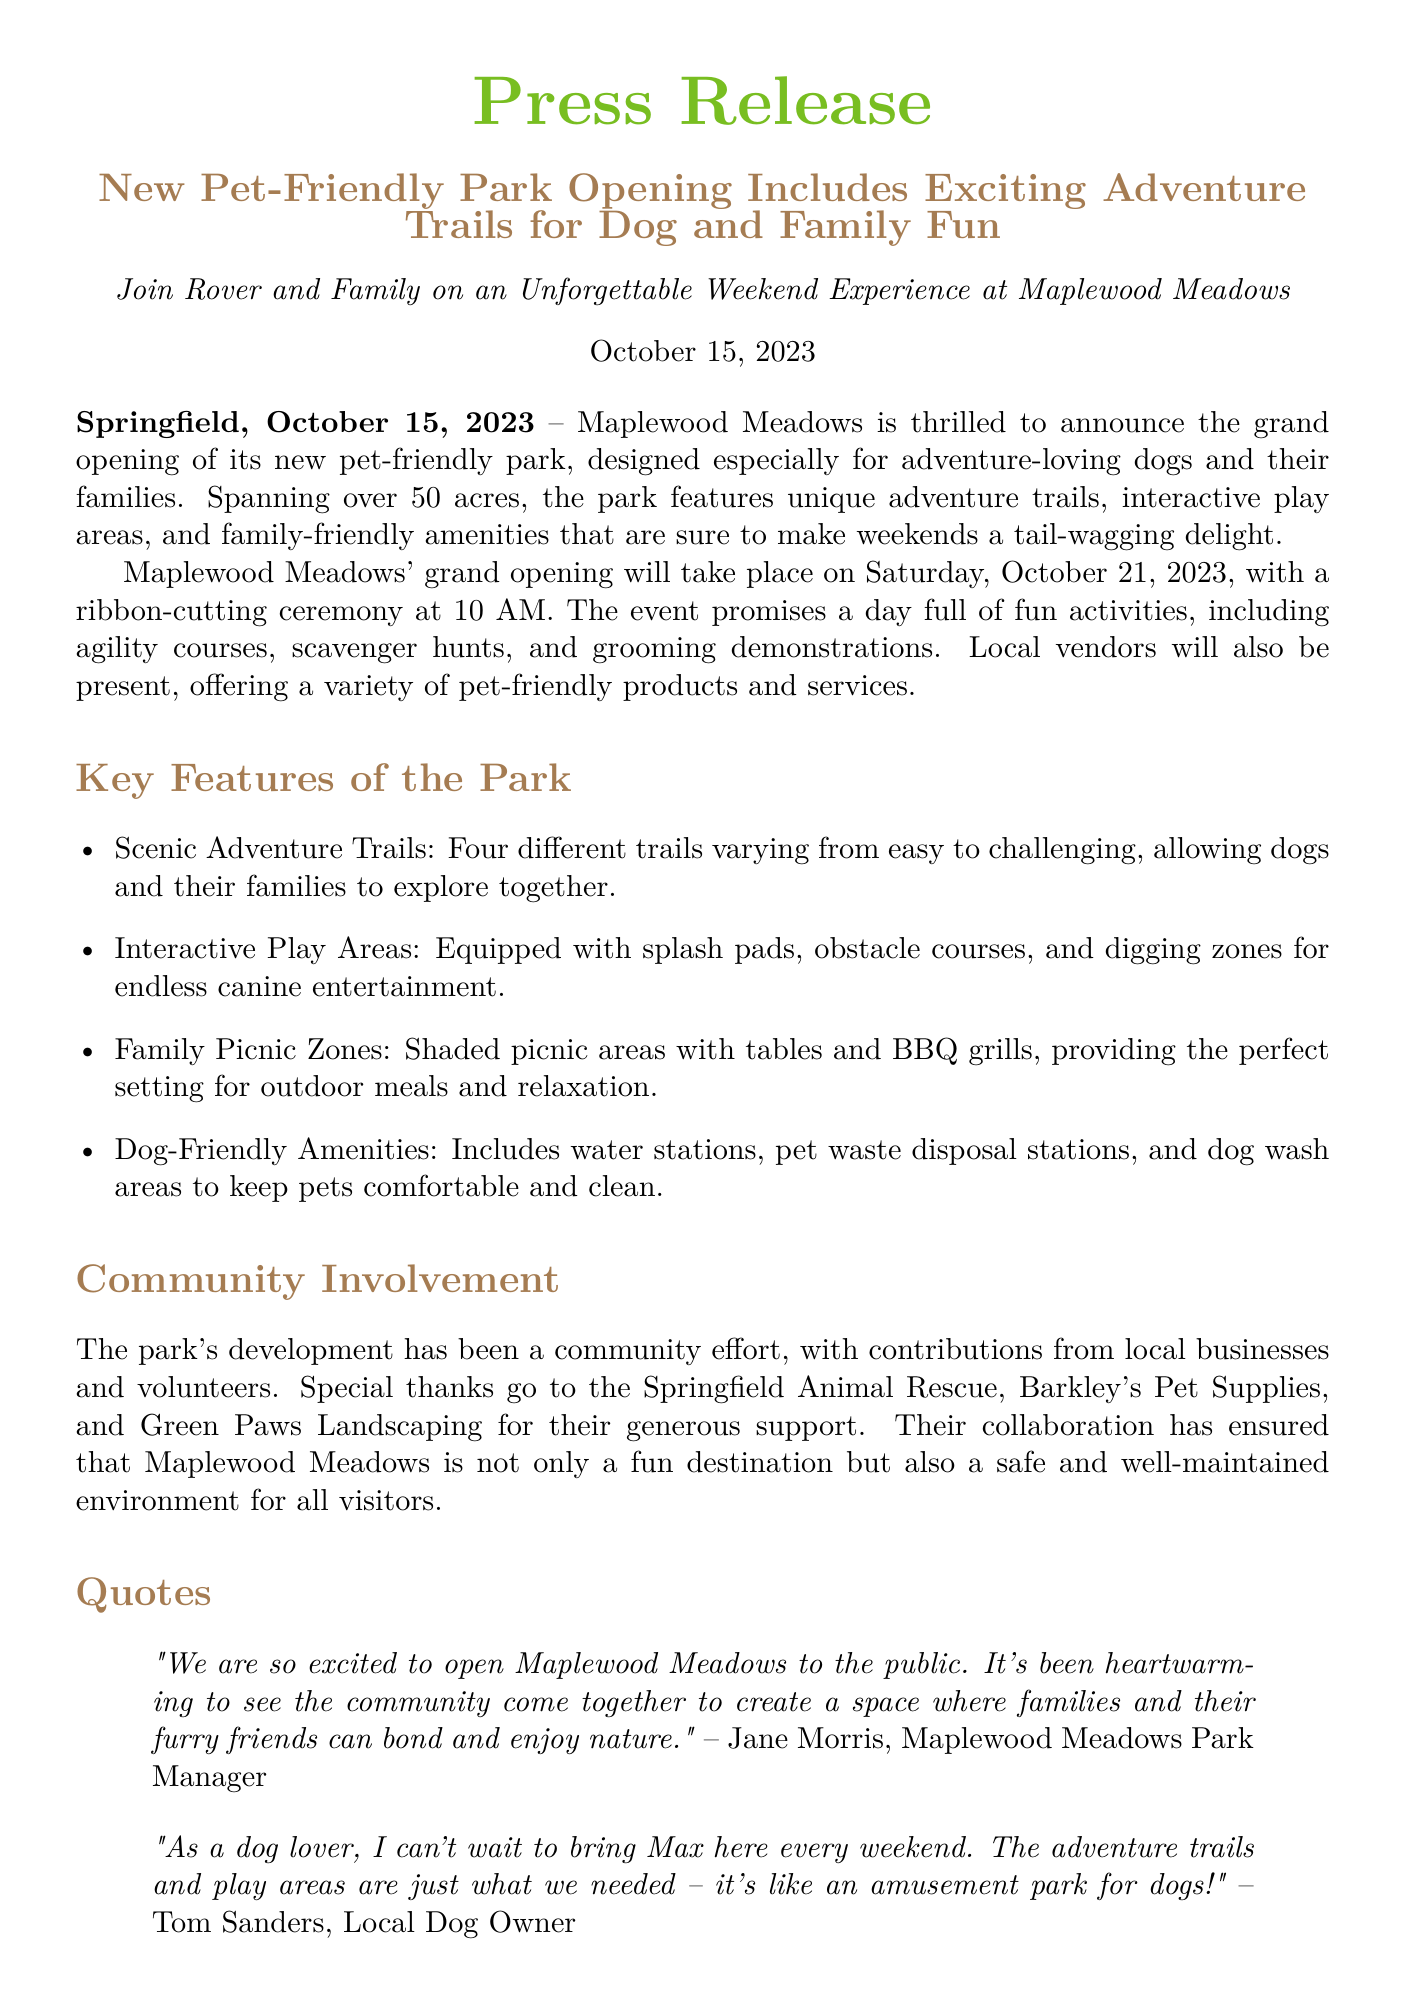What is the name of the new park? The park is named Maplewood Meadows, as mentioned in the title of the press release.
Answer: Maplewood Meadows When is the grand opening scheduled? The grand opening is mentioned to take place on Saturday, October 21, 2023, in the press release.
Answer: October 21, 2023 How many acres does the park cover? The press release states that the park spans over 50 acres.
Answer: 50 acres What types of activities are planned for the grand opening event? The document lists activities like agility courses, scavenger hunts, and grooming demonstrations for the grand opening.
Answer: Agility courses, scavenger hunts, grooming demonstrations Who is the Park Manager quoted in the press release? The press release features a quote from Jane Morris, identified as the Park Manager.
Answer: Jane Morris What organization contributed to the park's development? The press release mentions contributions from local businesses like Springfield Animal Rescue, implying community involvement.
Answer: Springfield Animal Rescue What is one of the features specifically for dogs mentioned in the park? The document highlights dog wash areas as one of the dog-friendly amenities in the park.
Answer: Dog wash areas What color is used for the title in the document? The title of the press release is in a color described as dogbrown in the document.
Answer: dogbrown What is the contact phone number for more information? The press release provides a specific phone number for inquiries, which is 555-123-4567.
Answer: 555-123-4567 